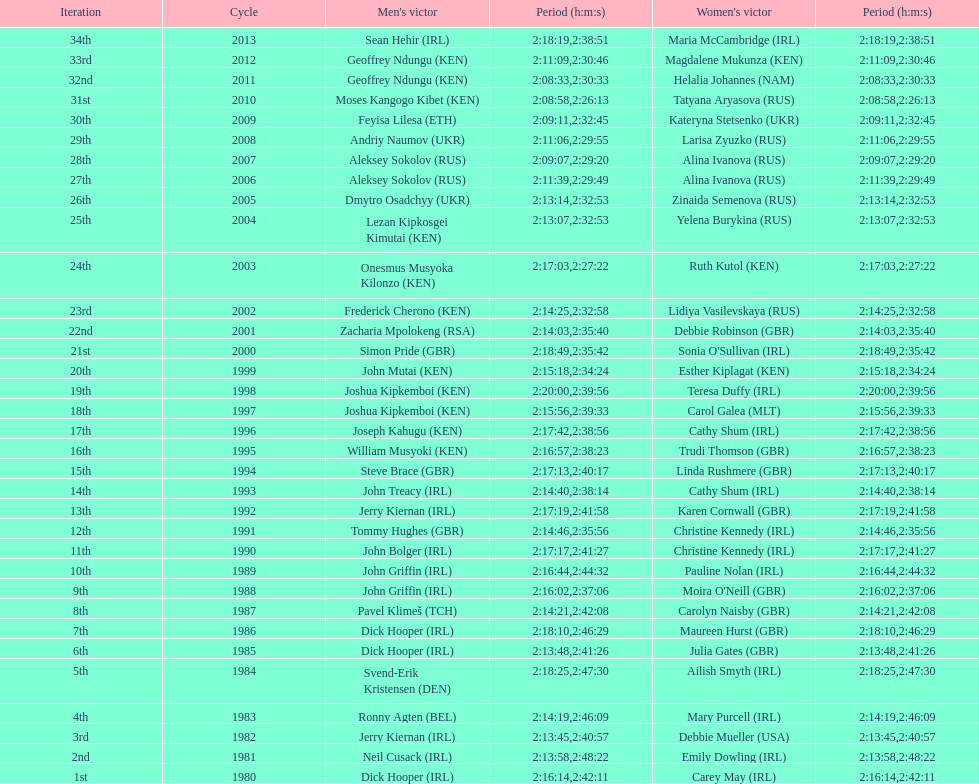How many women's winners are from kenya? 3. Could you parse the entire table? {'header': ['Iteration', 'Cycle', "Men's victor", 'Period (h:m:s)', "Women's victor", 'Period (h:m:s)'], 'rows': [['34th', '2013', 'Sean Hehir\xa0(IRL)', '2:18:19', 'Maria McCambridge\xa0(IRL)', '2:38:51'], ['33rd', '2012', 'Geoffrey Ndungu\xa0(KEN)', '2:11:09', 'Magdalene Mukunza\xa0(KEN)', '2:30:46'], ['32nd', '2011', 'Geoffrey Ndungu\xa0(KEN)', '2:08:33', 'Helalia Johannes\xa0(NAM)', '2:30:33'], ['31st', '2010', 'Moses Kangogo Kibet\xa0(KEN)', '2:08:58', 'Tatyana Aryasova\xa0(RUS)', '2:26:13'], ['30th', '2009', 'Feyisa Lilesa\xa0(ETH)', '2:09:11', 'Kateryna Stetsenko\xa0(UKR)', '2:32:45'], ['29th', '2008', 'Andriy Naumov\xa0(UKR)', '2:11:06', 'Larisa Zyuzko\xa0(RUS)', '2:29:55'], ['28th', '2007', 'Aleksey Sokolov\xa0(RUS)', '2:09:07', 'Alina Ivanova\xa0(RUS)', '2:29:20'], ['27th', '2006', 'Aleksey Sokolov\xa0(RUS)', '2:11:39', 'Alina Ivanova\xa0(RUS)', '2:29:49'], ['26th', '2005', 'Dmytro Osadchyy\xa0(UKR)', '2:13:14', 'Zinaida Semenova\xa0(RUS)', '2:32:53'], ['25th', '2004', 'Lezan Kipkosgei Kimutai\xa0(KEN)', '2:13:07', 'Yelena Burykina\xa0(RUS)', '2:32:53'], ['24th', '2003', 'Onesmus Musyoka Kilonzo\xa0(KEN)', '2:17:03', 'Ruth Kutol\xa0(KEN)', '2:27:22'], ['23rd', '2002', 'Frederick Cherono\xa0(KEN)', '2:14:25', 'Lidiya Vasilevskaya\xa0(RUS)', '2:32:58'], ['22nd', '2001', 'Zacharia Mpolokeng\xa0(RSA)', '2:14:03', 'Debbie Robinson\xa0(GBR)', '2:35:40'], ['21st', '2000', 'Simon Pride\xa0(GBR)', '2:18:49', "Sonia O'Sullivan\xa0(IRL)", '2:35:42'], ['20th', '1999', 'John Mutai\xa0(KEN)', '2:15:18', 'Esther Kiplagat\xa0(KEN)', '2:34:24'], ['19th', '1998', 'Joshua Kipkemboi\xa0(KEN)', '2:20:00', 'Teresa Duffy\xa0(IRL)', '2:39:56'], ['18th', '1997', 'Joshua Kipkemboi\xa0(KEN)', '2:15:56', 'Carol Galea\xa0(MLT)', '2:39:33'], ['17th', '1996', 'Joseph Kahugu\xa0(KEN)', '2:17:42', 'Cathy Shum\xa0(IRL)', '2:38:56'], ['16th', '1995', 'William Musyoki\xa0(KEN)', '2:16:57', 'Trudi Thomson\xa0(GBR)', '2:38:23'], ['15th', '1994', 'Steve Brace\xa0(GBR)', '2:17:13', 'Linda Rushmere\xa0(GBR)', '2:40:17'], ['14th', '1993', 'John Treacy\xa0(IRL)', '2:14:40', 'Cathy Shum\xa0(IRL)', '2:38:14'], ['13th', '1992', 'Jerry Kiernan\xa0(IRL)', '2:17:19', 'Karen Cornwall\xa0(GBR)', '2:41:58'], ['12th', '1991', 'Tommy Hughes\xa0(GBR)', '2:14:46', 'Christine Kennedy\xa0(IRL)', '2:35:56'], ['11th', '1990', 'John Bolger\xa0(IRL)', '2:17:17', 'Christine Kennedy\xa0(IRL)', '2:41:27'], ['10th', '1989', 'John Griffin\xa0(IRL)', '2:16:44', 'Pauline Nolan\xa0(IRL)', '2:44:32'], ['9th', '1988', 'John Griffin\xa0(IRL)', '2:16:02', "Moira O'Neill\xa0(GBR)", '2:37:06'], ['8th', '1987', 'Pavel Klimeš\xa0(TCH)', '2:14:21', 'Carolyn Naisby\xa0(GBR)', '2:42:08'], ['7th', '1986', 'Dick Hooper\xa0(IRL)', '2:18:10', 'Maureen Hurst\xa0(GBR)', '2:46:29'], ['6th', '1985', 'Dick Hooper\xa0(IRL)', '2:13:48', 'Julia Gates\xa0(GBR)', '2:41:26'], ['5th', '1984', 'Svend-Erik Kristensen\xa0(DEN)', '2:18:25', 'Ailish Smyth\xa0(IRL)', '2:47:30'], ['4th', '1983', 'Ronny Agten\xa0(BEL)', '2:14:19', 'Mary Purcell\xa0(IRL)', '2:46:09'], ['3rd', '1982', 'Jerry Kiernan\xa0(IRL)', '2:13:45', 'Debbie Mueller\xa0(USA)', '2:40:57'], ['2nd', '1981', 'Neil Cusack\xa0(IRL)', '2:13:58', 'Emily Dowling\xa0(IRL)', '2:48:22'], ['1st', '1980', 'Dick Hooper\xa0(IRL)', '2:16:14', 'Carey May\xa0(IRL)', '2:42:11']]} 